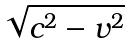<formula> <loc_0><loc_0><loc_500><loc_500>\sqrt { c ^ { 2 } - v ^ { 2 } }</formula> 